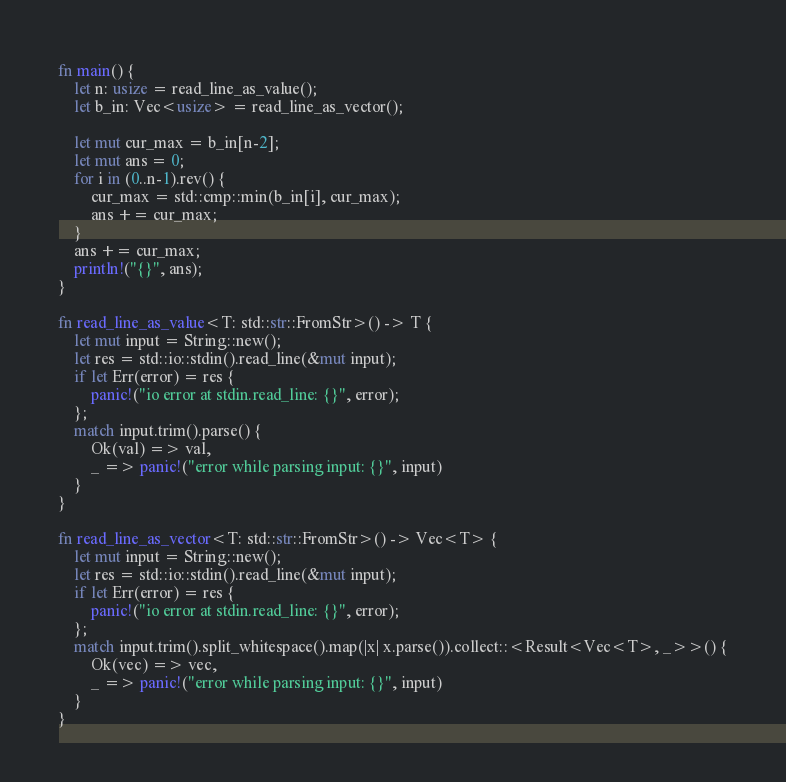<code> <loc_0><loc_0><loc_500><loc_500><_Rust_>fn main() {
    let n: usize = read_line_as_value();
    let b_in: Vec<usize> = read_line_as_vector();

    let mut cur_max = b_in[n-2];
    let mut ans = 0;
    for i in (0..n-1).rev() {
        cur_max = std::cmp::min(b_in[i], cur_max);
        ans += cur_max;
    }
    ans += cur_max;
    println!("{}", ans);
}

fn read_line_as_value<T: std::str::FromStr>() -> T {
    let mut input = String::new();
    let res = std::io::stdin().read_line(&mut input);
    if let Err(error) = res {
        panic!("io error at stdin.read_line: {}", error);
    };
    match input.trim().parse() {
        Ok(val) => val,
        _ => panic!("error while parsing input: {}", input)
    }
}

fn read_line_as_vector<T: std::str::FromStr>() -> Vec<T> {
    let mut input = String::new();
    let res = std::io::stdin().read_line(&mut input);
    if let Err(error) = res {
        panic!("io error at stdin.read_line: {}", error);
    };
    match input.trim().split_whitespace().map(|x| x.parse()).collect::<Result<Vec<T>, _>>() {
        Ok(vec) => vec,
        _ => panic!("error while parsing input: {}", input)
    }
}</code> 